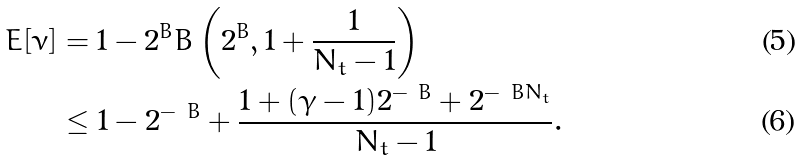Convert formula to latex. <formula><loc_0><loc_0><loc_500><loc_500>E [ \nu ] & = 1 - 2 ^ { B } B \left ( 2 ^ { B } , 1 + \frac { 1 } { N _ { t } - 1 } \right ) \\ & \leq 1 - 2 ^ { - \ B } + \frac { 1 + ( \gamma - 1 ) 2 ^ { - \ B } + 2 ^ { - \ B N _ { t } } } { N _ { t } - 1 } .</formula> 